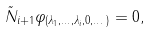<formula> <loc_0><loc_0><loc_500><loc_500>\tilde { N } _ { i + 1 } \varphi _ { ( \lambda _ { 1 } , \dots , \lambda _ { i } , 0 , \dots ) } = 0 ,</formula> 